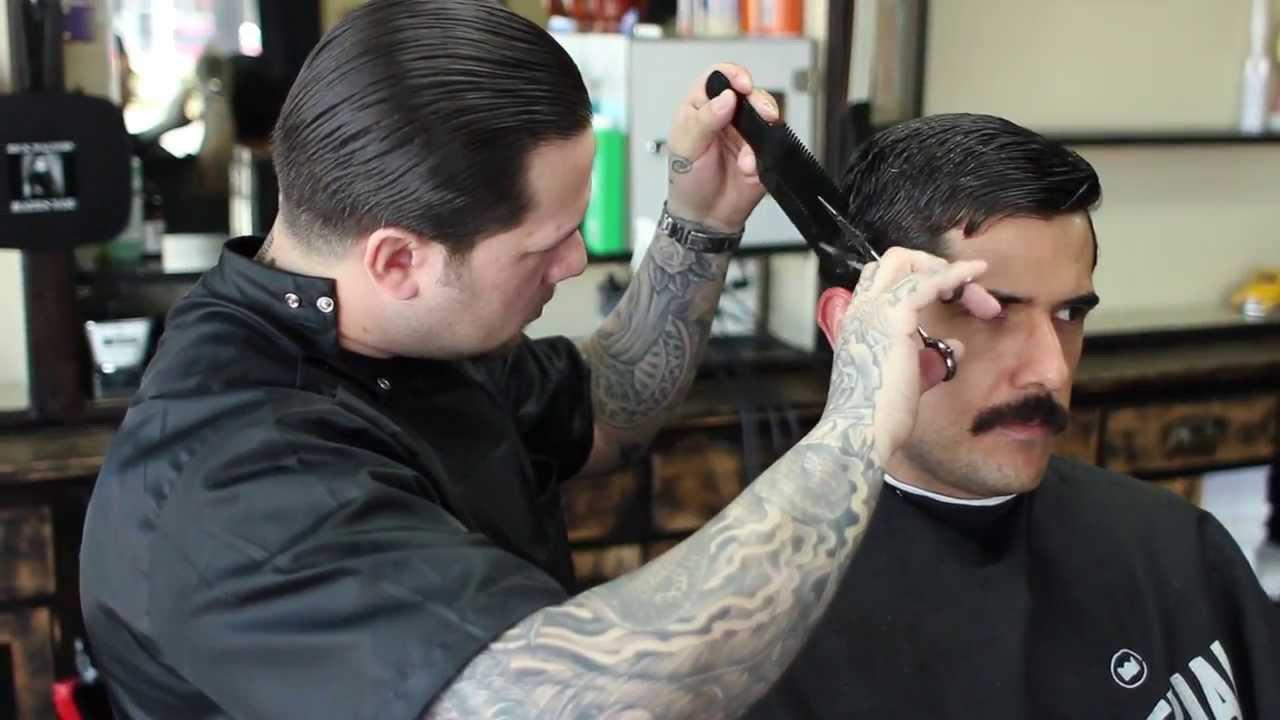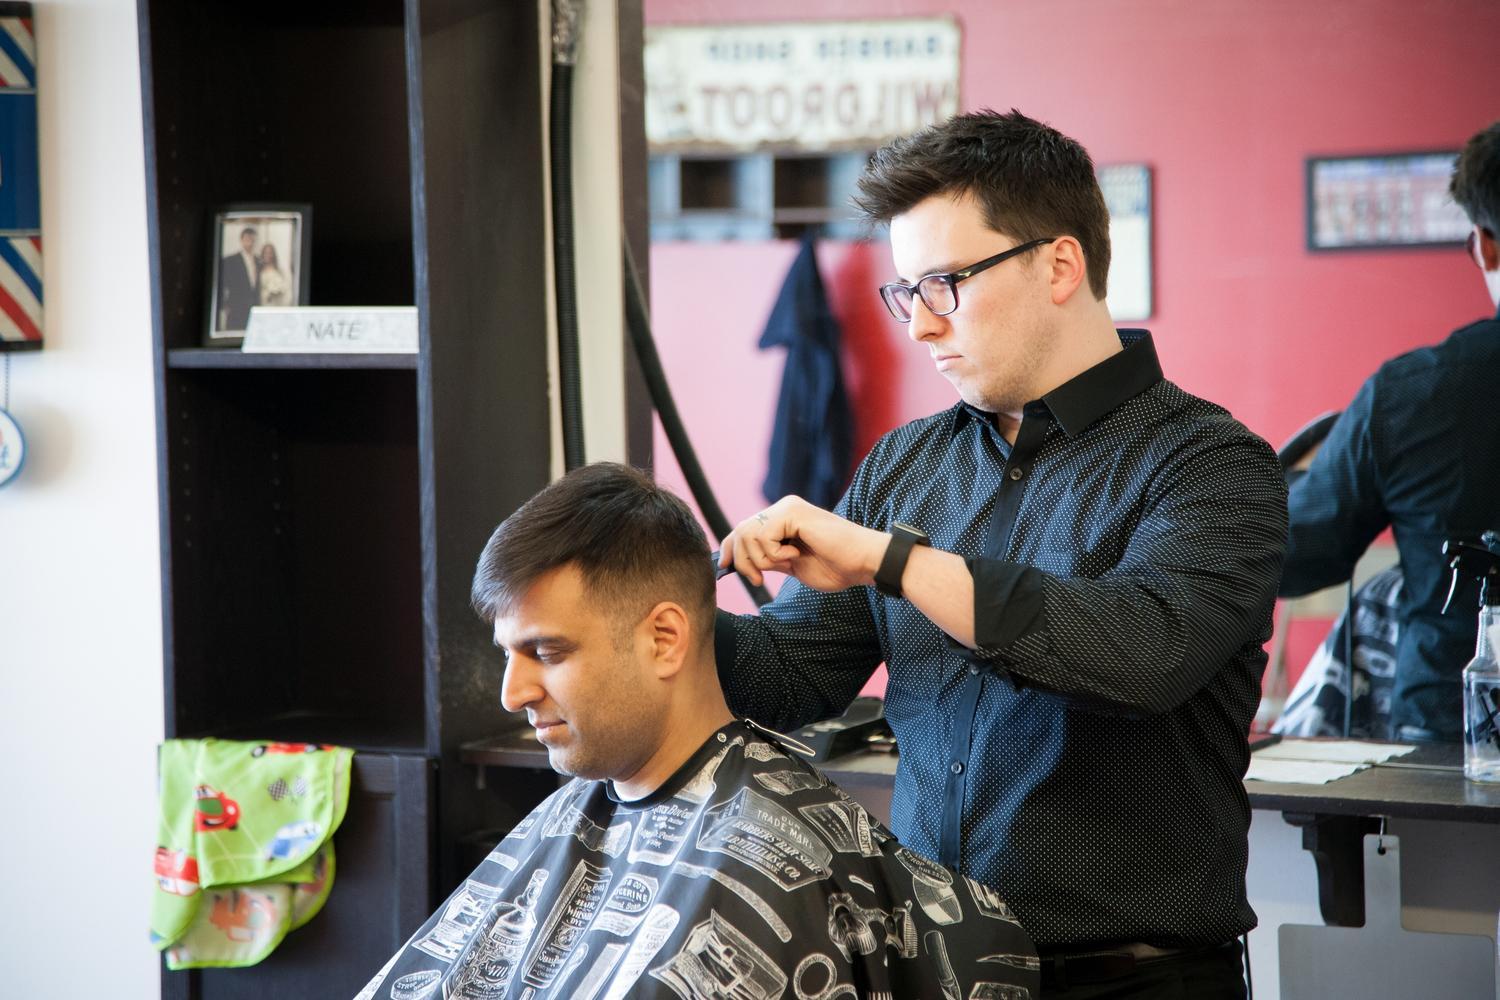The first image is the image on the left, the second image is the image on the right. Assess this claim about the two images: "The male barber in the image on the right is wearing glasses.". Correct or not? Answer yes or no. Yes. The first image is the image on the left, the second image is the image on the right. For the images displayed, is the sentence "An image shows a male barber with eyeglasses behind a customer, working on hair." factually correct? Answer yes or no. Yes. 